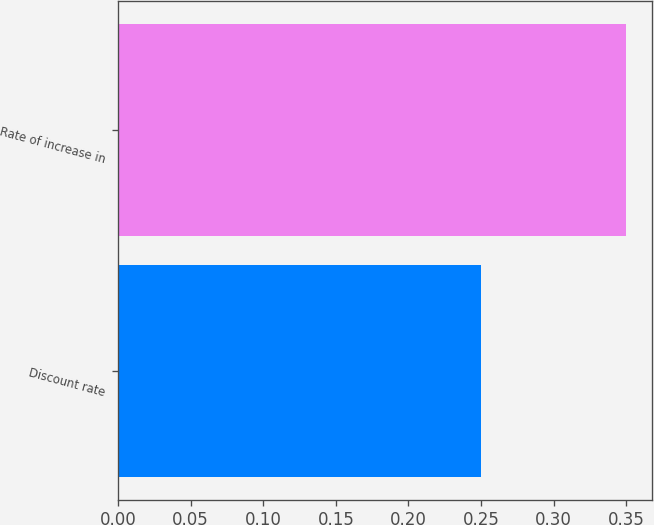Convert chart. <chart><loc_0><loc_0><loc_500><loc_500><bar_chart><fcel>Discount rate<fcel>Rate of increase in<nl><fcel>0.25<fcel>0.35<nl></chart> 